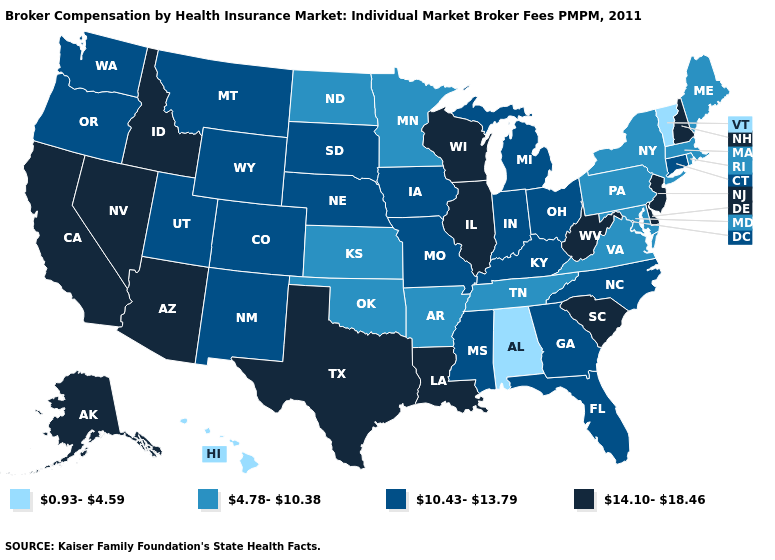Does New Hampshire have the highest value in the USA?
Write a very short answer. Yes. Does the first symbol in the legend represent the smallest category?
Quick response, please. Yes. Which states have the lowest value in the USA?
Short answer required. Alabama, Hawaii, Vermont. Name the states that have a value in the range 0.93-4.59?
Quick response, please. Alabama, Hawaii, Vermont. What is the highest value in the West ?
Concise answer only. 14.10-18.46. Name the states that have a value in the range 0.93-4.59?
Give a very brief answer. Alabama, Hawaii, Vermont. Name the states that have a value in the range 4.78-10.38?
Write a very short answer. Arkansas, Kansas, Maine, Maryland, Massachusetts, Minnesota, New York, North Dakota, Oklahoma, Pennsylvania, Rhode Island, Tennessee, Virginia. Does Tennessee have a lower value than Ohio?
Quick response, please. Yes. Name the states that have a value in the range 4.78-10.38?
Quick response, please. Arkansas, Kansas, Maine, Maryland, Massachusetts, Minnesota, New York, North Dakota, Oklahoma, Pennsylvania, Rhode Island, Tennessee, Virginia. Name the states that have a value in the range 0.93-4.59?
Answer briefly. Alabama, Hawaii, Vermont. Name the states that have a value in the range 0.93-4.59?
Answer briefly. Alabama, Hawaii, Vermont. Among the states that border Connecticut , which have the highest value?
Write a very short answer. Massachusetts, New York, Rhode Island. Name the states that have a value in the range 10.43-13.79?
Keep it brief. Colorado, Connecticut, Florida, Georgia, Indiana, Iowa, Kentucky, Michigan, Mississippi, Missouri, Montana, Nebraska, New Mexico, North Carolina, Ohio, Oregon, South Dakota, Utah, Washington, Wyoming. Among the states that border Texas , does Arkansas have the lowest value?
Keep it brief. Yes. Does Hawaii have the lowest value in the USA?
Answer briefly. Yes. 